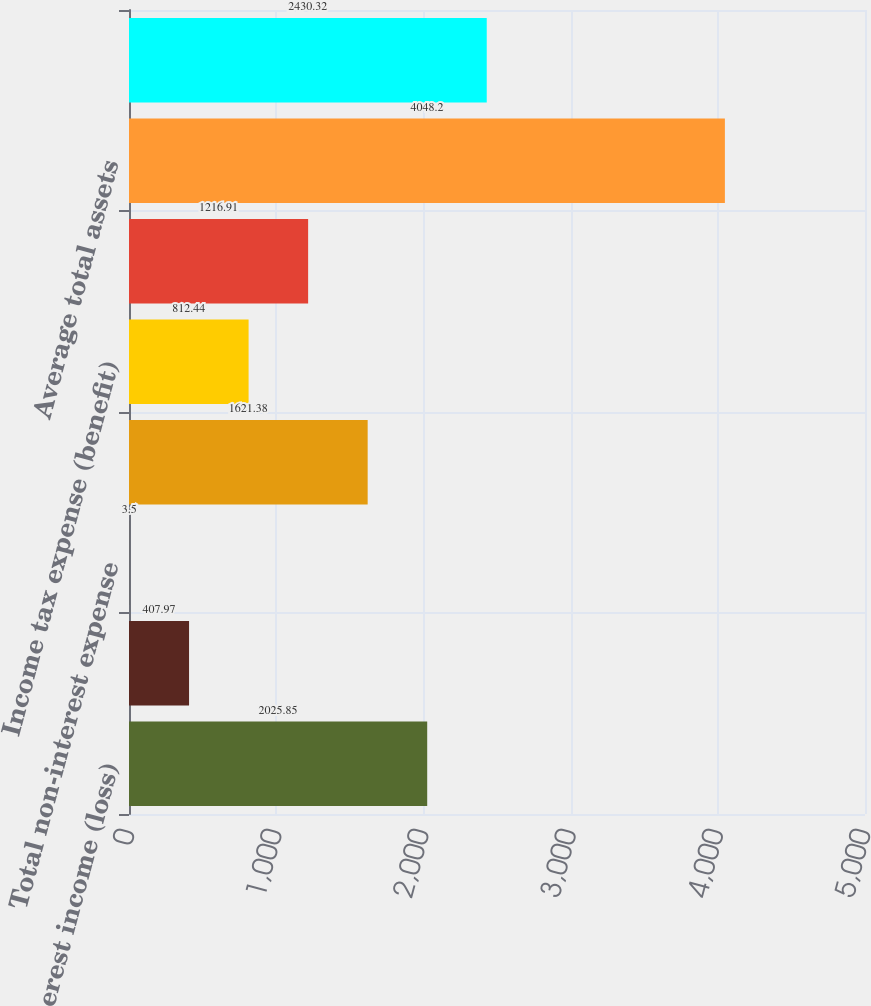Convert chart to OTSL. <chart><loc_0><loc_0><loc_500><loc_500><bar_chart><fcel>Net interest income (loss)<fcel>Total non-interest income<fcel>Total non-interest expense<fcel>Income (loss) before income<fcel>Income tax expense (benefit)<fcel>Net income (loss)<fcel>Average total assets<fcel>Average total liabilities<nl><fcel>2025.85<fcel>407.97<fcel>3.5<fcel>1621.38<fcel>812.44<fcel>1216.91<fcel>4048.2<fcel>2430.32<nl></chart> 